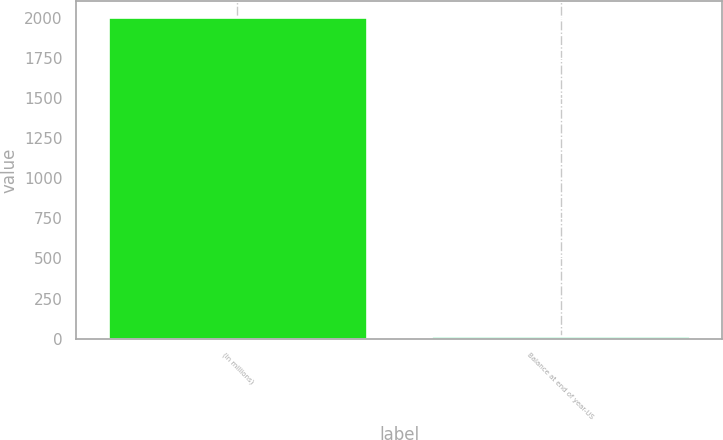Convert chart to OTSL. <chart><loc_0><loc_0><loc_500><loc_500><bar_chart><fcel>(In millions)<fcel>Balance at end of year-US<nl><fcel>2005<fcel>17<nl></chart> 